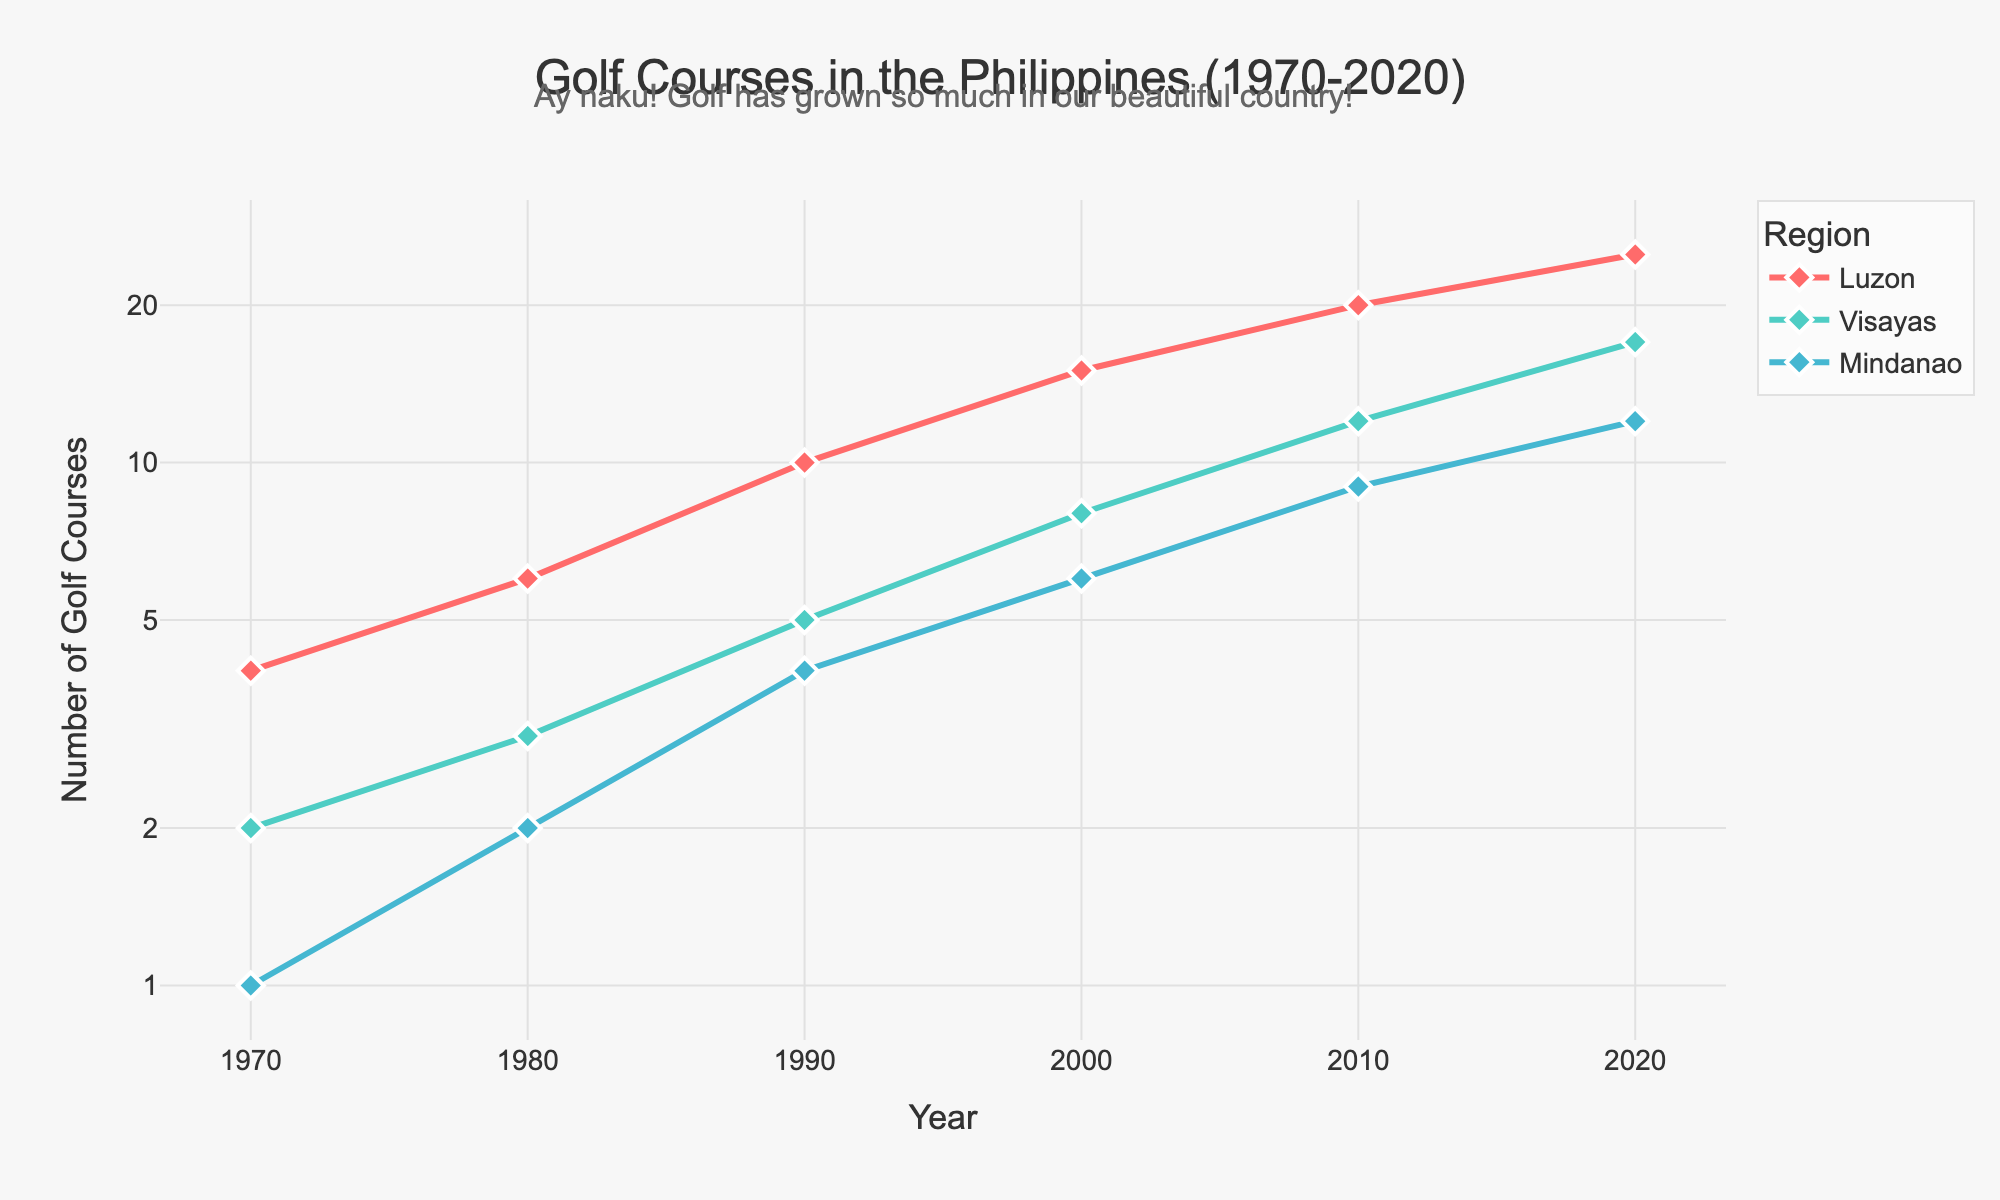Which region had the highest number of golf courses in 2020? To find the region with the highest number of golf courses in 2020, look at the end points of the lines for Luzon, Visayas, and Mindanao on the x-axis at 2020. Luzon shows the highest value.
Answer: Luzon How many golf courses were there in Visayas in 1980? First, locate the year 1980 on the x-axis. Then, follow up and check the data point for Visayas, indicated by the corresponding color. The number associated with Visayas in 1980 is 3.
Answer: 3 Between which decades did Mindanao see the greatest increase in the number of golf courses? Look for the segments of the Mindanao line where the increase is steepest between consecutive decades. The largest increase is from 2000 to 2010, from 6 to 9 golf courses.
Answer: 2000 to 2010 Which region had the fewest golf courses in 1970? To find the region with the fewest golf courses in 1970, look at the beginning points of the lines for Luzon, Visayas, and Mindanao. Mindanao shows the lowest value.
Answer: Mindanao What is the general trend for the number of golf courses in Luzon from 1970 to 2020? Observing the plot, the number of golf courses in Luzon consistently increases over time from 4 in 1970 to 25 in 2020, showing an overall upwards trend.
Answer: Increasing How many more golf courses were there in Luzon than in Mindanao in 1990? Look at 1990 and compare the data points for Luzon and Mindanao. Luzon had 10 golf courses, and Mindanao had 4, so the difference is 10 - 4.
Answer: 6 Which region had the second-highest number of golf courses in 2010? Looking at the year 2010 and comparing the data points for all three regions, Luzon had the highest, followed by Visayas at 12, making Visayas the second-highest.
Answer: Visayas By how many golf courses did Visayas grow from 2000 to 2020? Locate the number of golf courses for Visayas at 2000 (8) and 2020 (17) and then calculate the difference, 17 - 8.
Answer: 9 Out of the three regions, which one showed the most consistent growth trend in the number of golf courses from 1970 to 2020? By visually inspecting all three lines over the time period, Luzon shows the most consistent upward trend without any dips or dramatic changes.
Answer: Luzon 